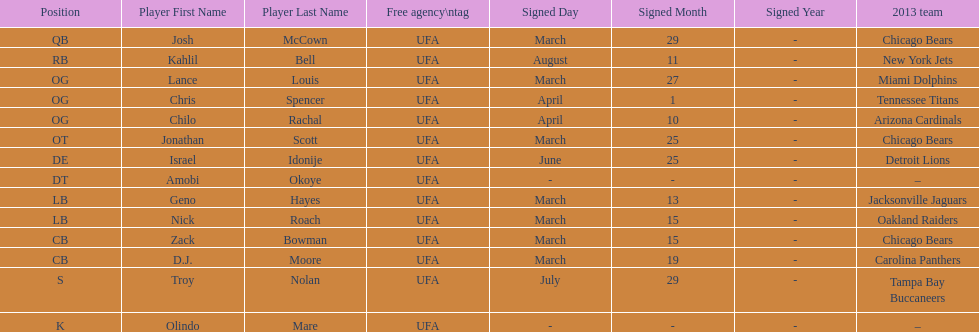Write the full table. {'header': ['Position', 'Player First Name', 'Player Last Name', 'Free agency\\ntag', 'Signed Day', 'Signed Month', 'Signed Year', '2013 team'], 'rows': [['QB', 'Josh', 'McCown', 'UFA', 'March', '29', '-', 'Chicago Bears'], ['RB', 'Kahlil', 'Bell', 'UFA', 'August', '11', '-', 'New York Jets'], ['OG', 'Lance', 'Louis', 'UFA', 'March', '27', '-', 'Miami Dolphins'], ['OG', 'Chris', 'Spencer', 'UFA', 'April', '1', '-', 'Tennessee Titans'], ['OG', 'Chilo', 'Rachal', 'UFA', 'April', '10', '-', 'Arizona Cardinals'], ['OT', 'Jonathan', 'Scott', 'UFA', 'March', '25', '-', 'Chicago Bears'], ['DE', 'Israel', 'Idonije', 'UFA', 'June', '25', '-', 'Detroit Lions'], ['DT', 'Amobi', 'Okoye', 'UFA', '-', '-', '-', '–'], ['LB', 'Geno', 'Hayes', 'UFA', 'March', '13', '-', 'Jacksonville Jaguars'], ['LB', 'Nick', 'Roach', 'UFA', 'March', '15', '-', 'Oakland Raiders'], ['CB', 'Zack', 'Bowman', 'UFA', 'March', '15', '-', 'Chicago Bears'], ['CB', 'D.J.', 'Moore', 'UFA', 'March', '19', '-', 'Carolina Panthers'], ['S', 'Troy', 'Nolan', 'UFA', 'July', '29', '-', 'Tampa Bay Buccaneers'], ['K', 'Olindo', 'Mare', 'UFA', '-', '-', '-', '–']]} Who was the previous player signed before troy nolan? Israel Idonije. 